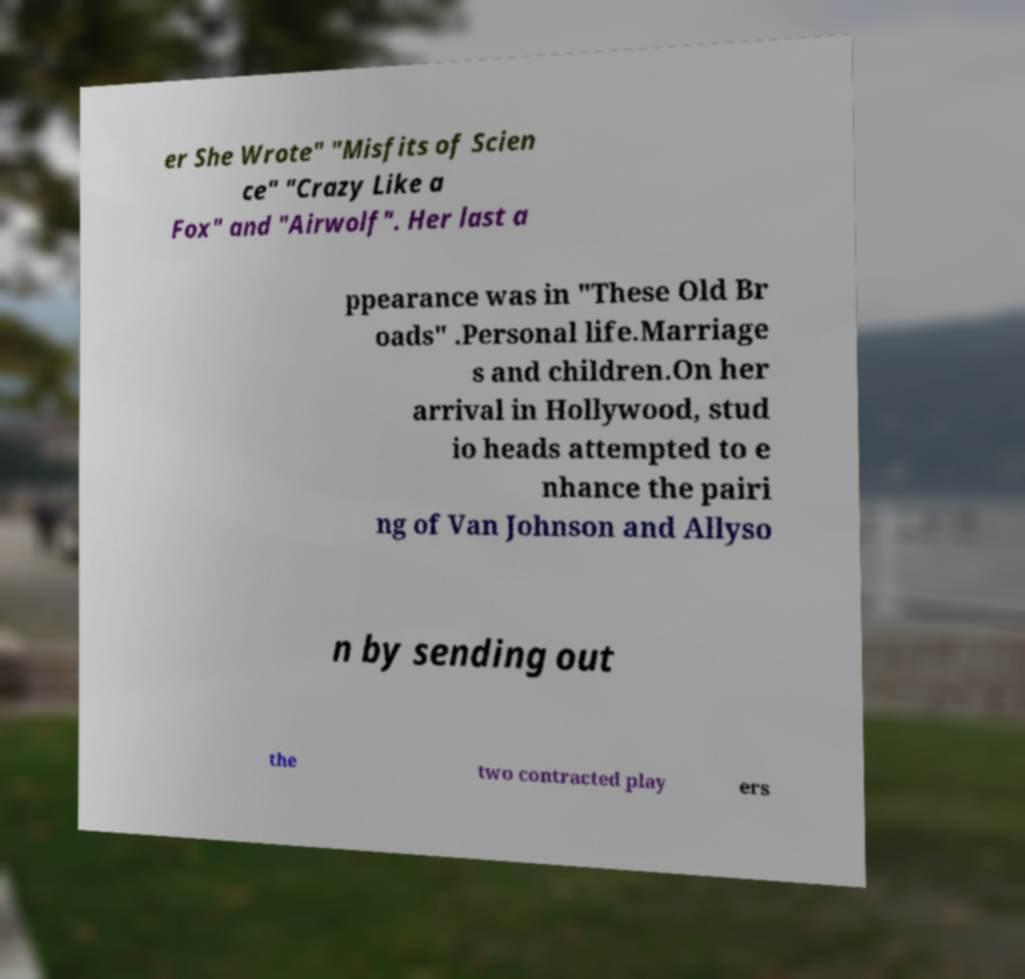Can you read and provide the text displayed in the image?This photo seems to have some interesting text. Can you extract and type it out for me? er She Wrote" "Misfits of Scien ce" "Crazy Like a Fox" and "Airwolf". Her last a ppearance was in "These Old Br oads" .Personal life.Marriage s and children.On her arrival in Hollywood, stud io heads attempted to e nhance the pairi ng of Van Johnson and Allyso n by sending out the two contracted play ers 